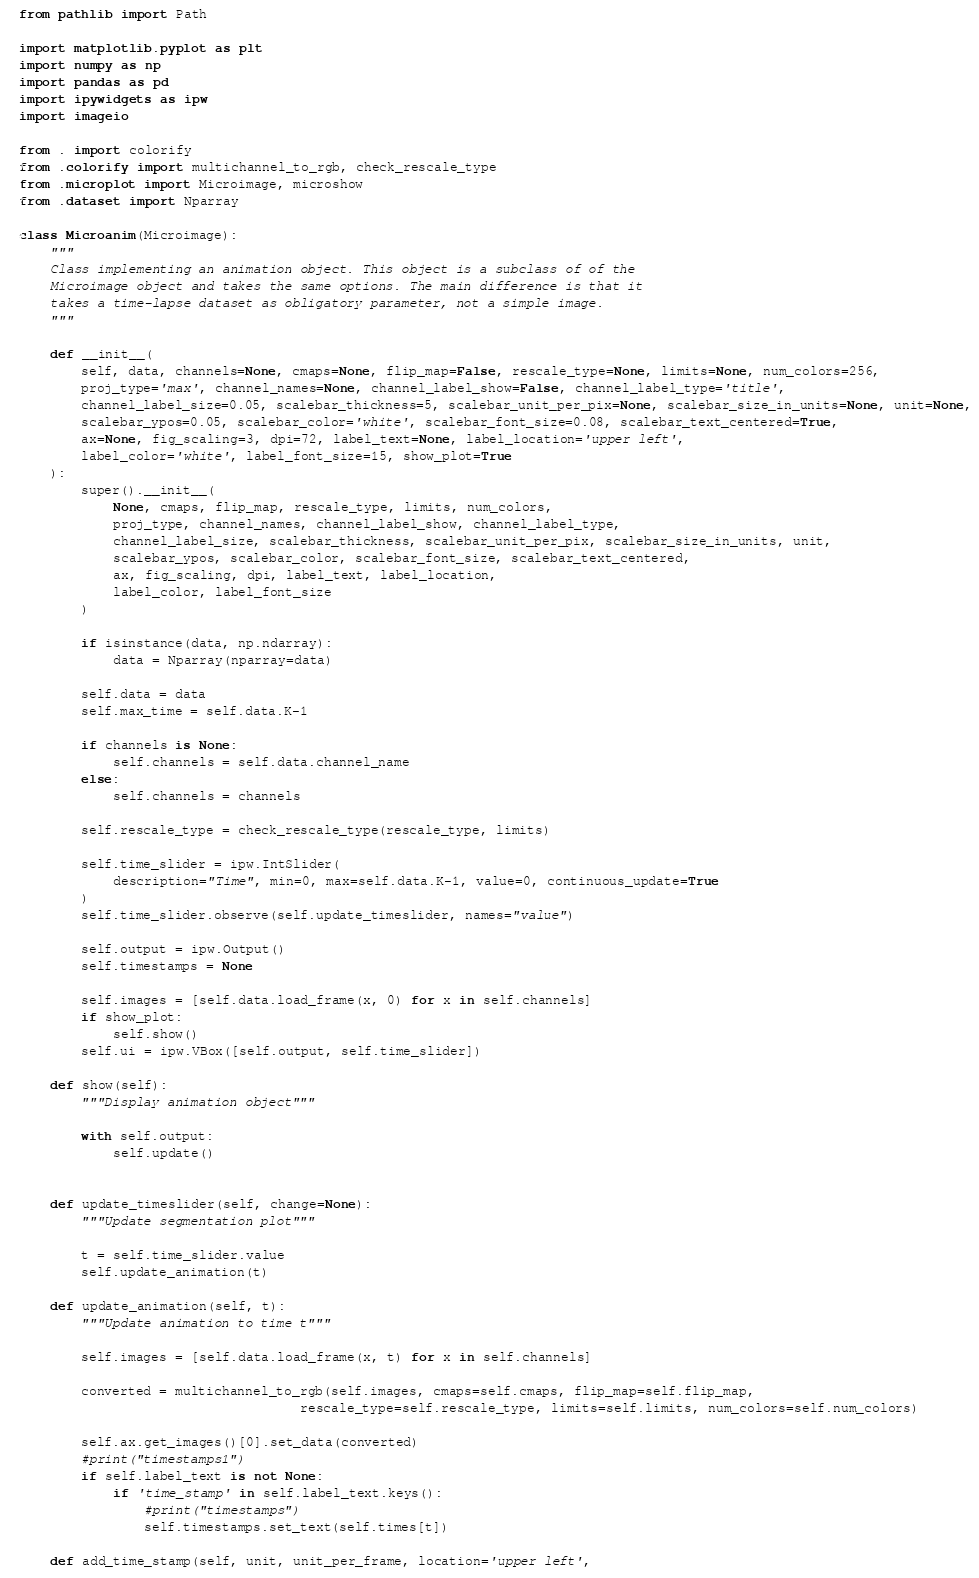<code> <loc_0><loc_0><loc_500><loc_500><_Python_>from pathlib import Path

import matplotlib.pyplot as plt
import numpy as np
import pandas as pd
import ipywidgets as ipw
import imageio

from . import colorify
from .colorify import multichannel_to_rgb, check_rescale_type
from .microplot import Microimage, microshow
from .dataset import Nparray

class Microanim(Microimage):
    """
    Class implementing an animation object. This object is a subclass of of the
    Microimage object and takes the same options. The main difference is that it
    takes a time-lapse dataset as obligatory parameter, not a simple image.
    """

    def __init__(
        self, data, channels=None, cmaps=None, flip_map=False, rescale_type=None, limits=None, num_colors=256,
        proj_type='max', channel_names=None, channel_label_show=False, channel_label_type='title',
        channel_label_size=0.05, scalebar_thickness=5, scalebar_unit_per_pix=None, scalebar_size_in_units=None, unit=None,
        scalebar_ypos=0.05, scalebar_color='white', scalebar_font_size=0.08, scalebar_text_centered=True,
        ax=None, fig_scaling=3, dpi=72, label_text=None, label_location='upper left',
        label_color='white', label_font_size=15, show_plot=True
    ):
        super().__init__(
            None, cmaps, flip_map, rescale_type, limits, num_colors,
            proj_type, channel_names, channel_label_show, channel_label_type,
            channel_label_size, scalebar_thickness, scalebar_unit_per_pix, scalebar_size_in_units, unit,
            scalebar_ypos, scalebar_color, scalebar_font_size, scalebar_text_centered,
            ax, fig_scaling, dpi, label_text, label_location,
            label_color, label_font_size
        )

        if isinstance(data, np.ndarray):
            data = Nparray(nparray=data)

        self.data = data
        self.max_time = self.data.K-1
        
        if channels is None:
            self.channels = self.data.channel_name
        else:
            self.channels = channels
        
        self.rescale_type = check_rescale_type(rescale_type, limits)

        self.time_slider = ipw.IntSlider(
            description="Time", min=0, max=self.data.K-1, value=0, continuous_update=True
        )
        self.time_slider.observe(self.update_timeslider, names="value")

        self.output = ipw.Output()
        self.timestamps = None

        self.images = [self.data.load_frame(x, 0) for x in self.channels]
        if show_plot:
            self.show()
        self.ui = ipw.VBox([self.output, self.time_slider])

    def show(self):
        """Display animation object"""

        with self.output:
            self.update()


    def update_timeslider(self, change=None):
        """Update segmentation plot"""

        t = self.time_slider.value
        self.update_animation(t)
        
    def update_animation(self, t):
        """Update animation to time t"""

        self.images = [self.data.load_frame(x, t) for x in self.channels]

        converted = multichannel_to_rgb(self.images, cmaps=self.cmaps, flip_map=self.flip_map,
                                    rescale_type=self.rescale_type, limits=self.limits, num_colors=self.num_colors)

        self.ax.get_images()[0].set_data(converted)
        #print("timestamps1")
        if self.label_text is not None:
            if 'time_stamp' in self.label_text.keys():
                #print("timestamps")
                self.timestamps.set_text(self.times[t])

    def add_time_stamp(self, unit, unit_per_frame, location='upper left',</code> 